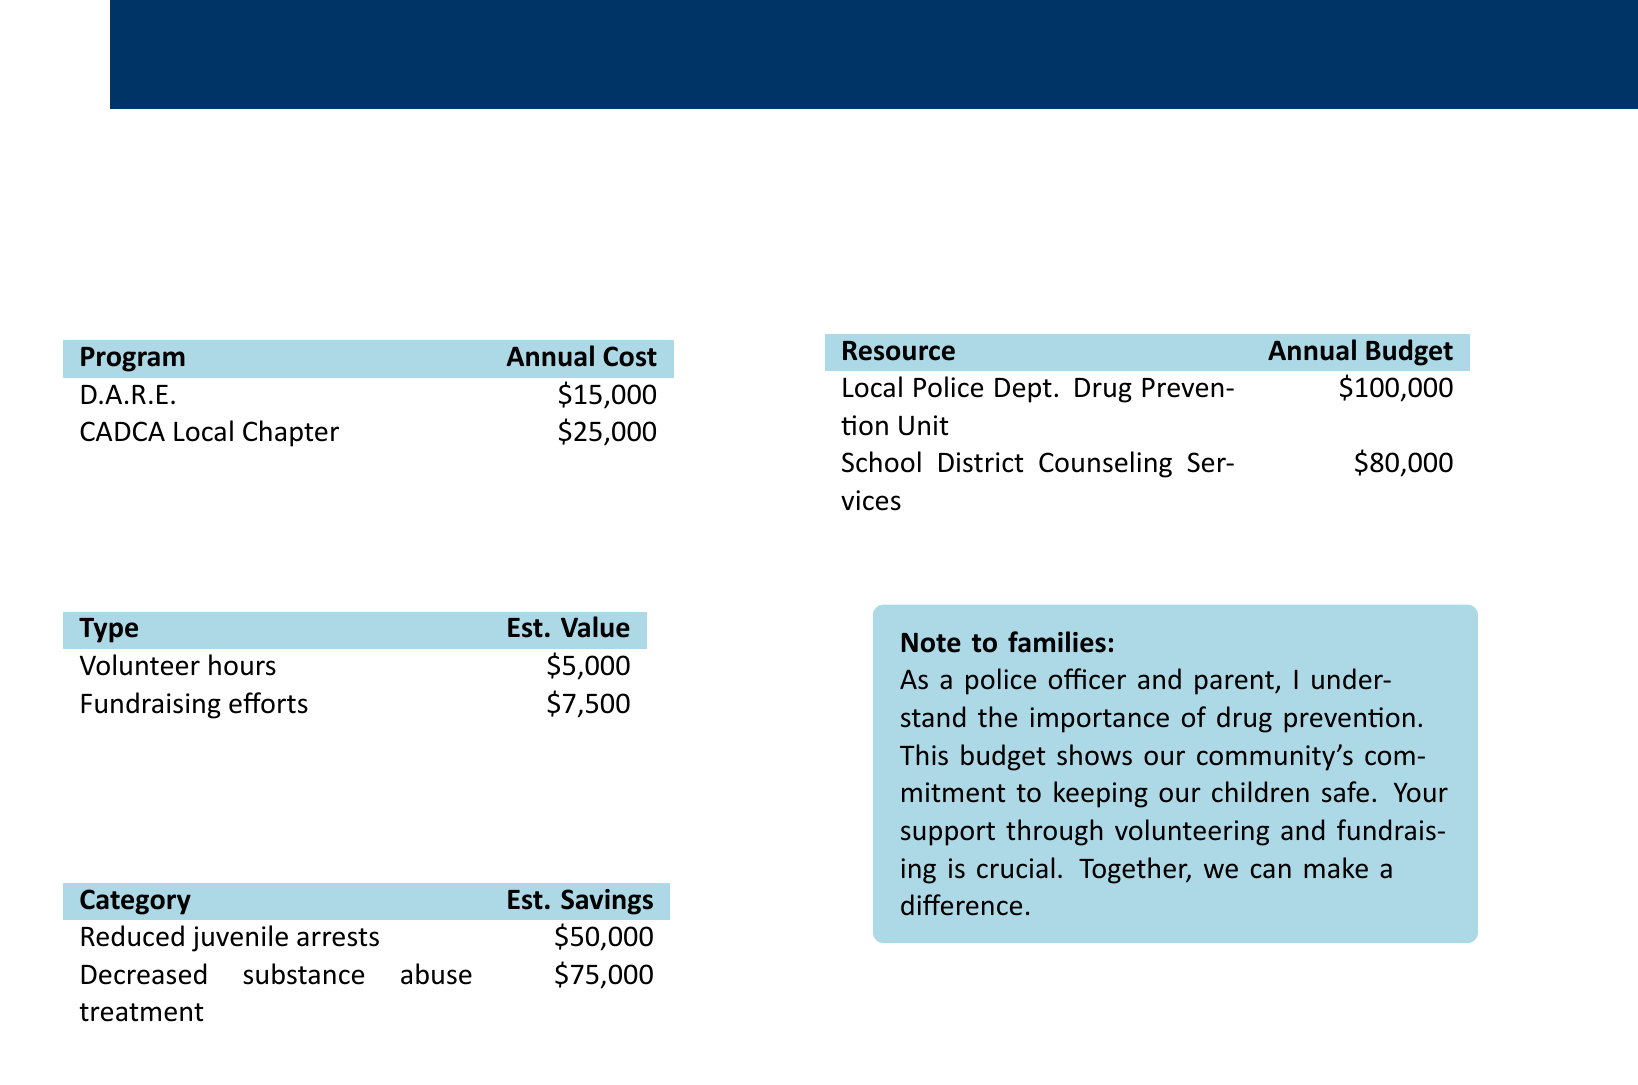What is the annual cost of the D.A.R.E. program? The annual cost of the D.A.R.E. program is listed in the program costs section.
Answer: $15,000 What is the estimated value of volunteer hours? The estimated value of volunteer hours can be found in the family contributions section of the document.
Answer: $5,000 How much does the local police department's drug prevention unit have as an annual budget? The annual budget for the local police department's drug prevention unit is specified in the additional resources section.
Answer: $100,000 What is the total estimated savings from reduced juvenile arrests and decreased substance abuse treatment? This total is the sum of the estimates for reduced juvenile arrests and decreased substance abuse treatment from the potential savings section.
Answer: $125,000 What fundraising efforts contribute to the family contributions? The family contributions section lists fundraising efforts that contribute to the program's value.
Answer: $7,500 How many programs are listed in the program costs? The program costs section details the number of individual programs that have associated costs.
Answer: 2 What are the potential savings from decreased substance abuse treatment? The potential savings from decreased substance abuse treatment is provided in the savings section of the document.
Answer: $75,000 What type of resources does the school district provide? The document mentions resources provided by the school district within the additional resources section.
Answer: Counseling Services What is the total contribution from both volunteer hours and fundraising efforts? This total is calculated by adding the estimated values of volunteer hours and fundraising efforts from the family contributions section.
Answer: $12,500 